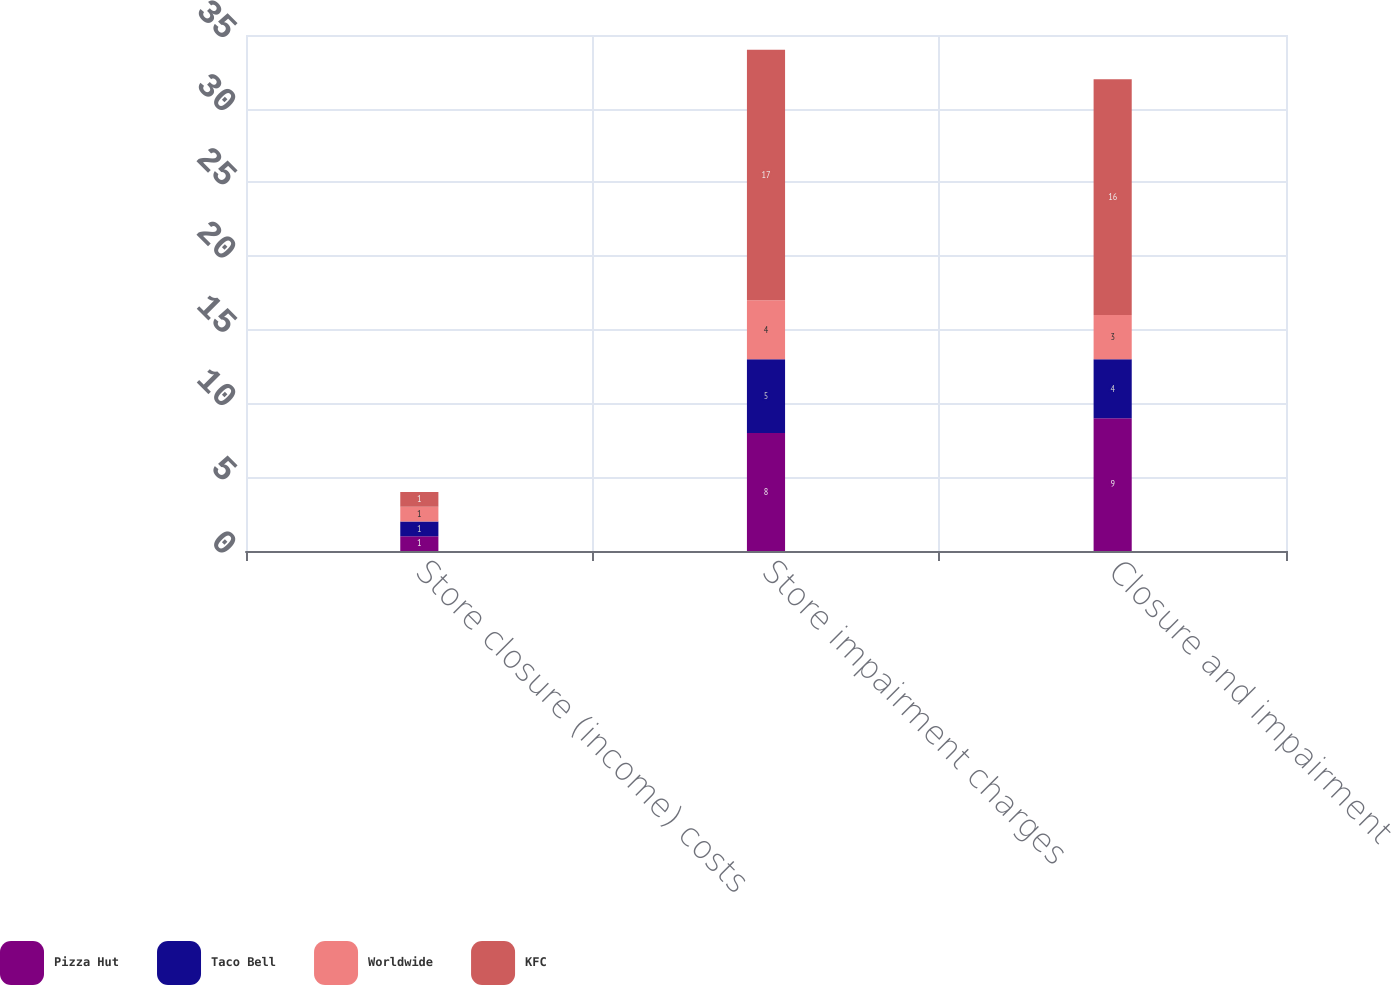Convert chart. <chart><loc_0><loc_0><loc_500><loc_500><stacked_bar_chart><ecel><fcel>Store closure (income) costs<fcel>Store impairment charges<fcel>Closure and impairment<nl><fcel>Pizza Hut<fcel>1<fcel>8<fcel>9<nl><fcel>Taco Bell<fcel>1<fcel>5<fcel>4<nl><fcel>Worldwide<fcel>1<fcel>4<fcel>3<nl><fcel>KFC<fcel>1<fcel>17<fcel>16<nl></chart> 